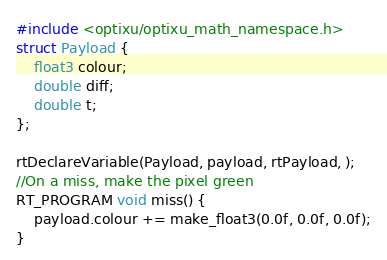<code> <loc_0><loc_0><loc_500><loc_500><_Cuda_>#include <optixu/optixu_math_namespace.h>
struct Payload {
	float3 colour;
	double diff;
	double t;
};

rtDeclareVariable(Payload, payload, rtPayload, );
//On a miss, make the pixel green
RT_PROGRAM void miss() {
	payload.colour += make_float3(0.0f, 0.0f, 0.0f);
}</code> 